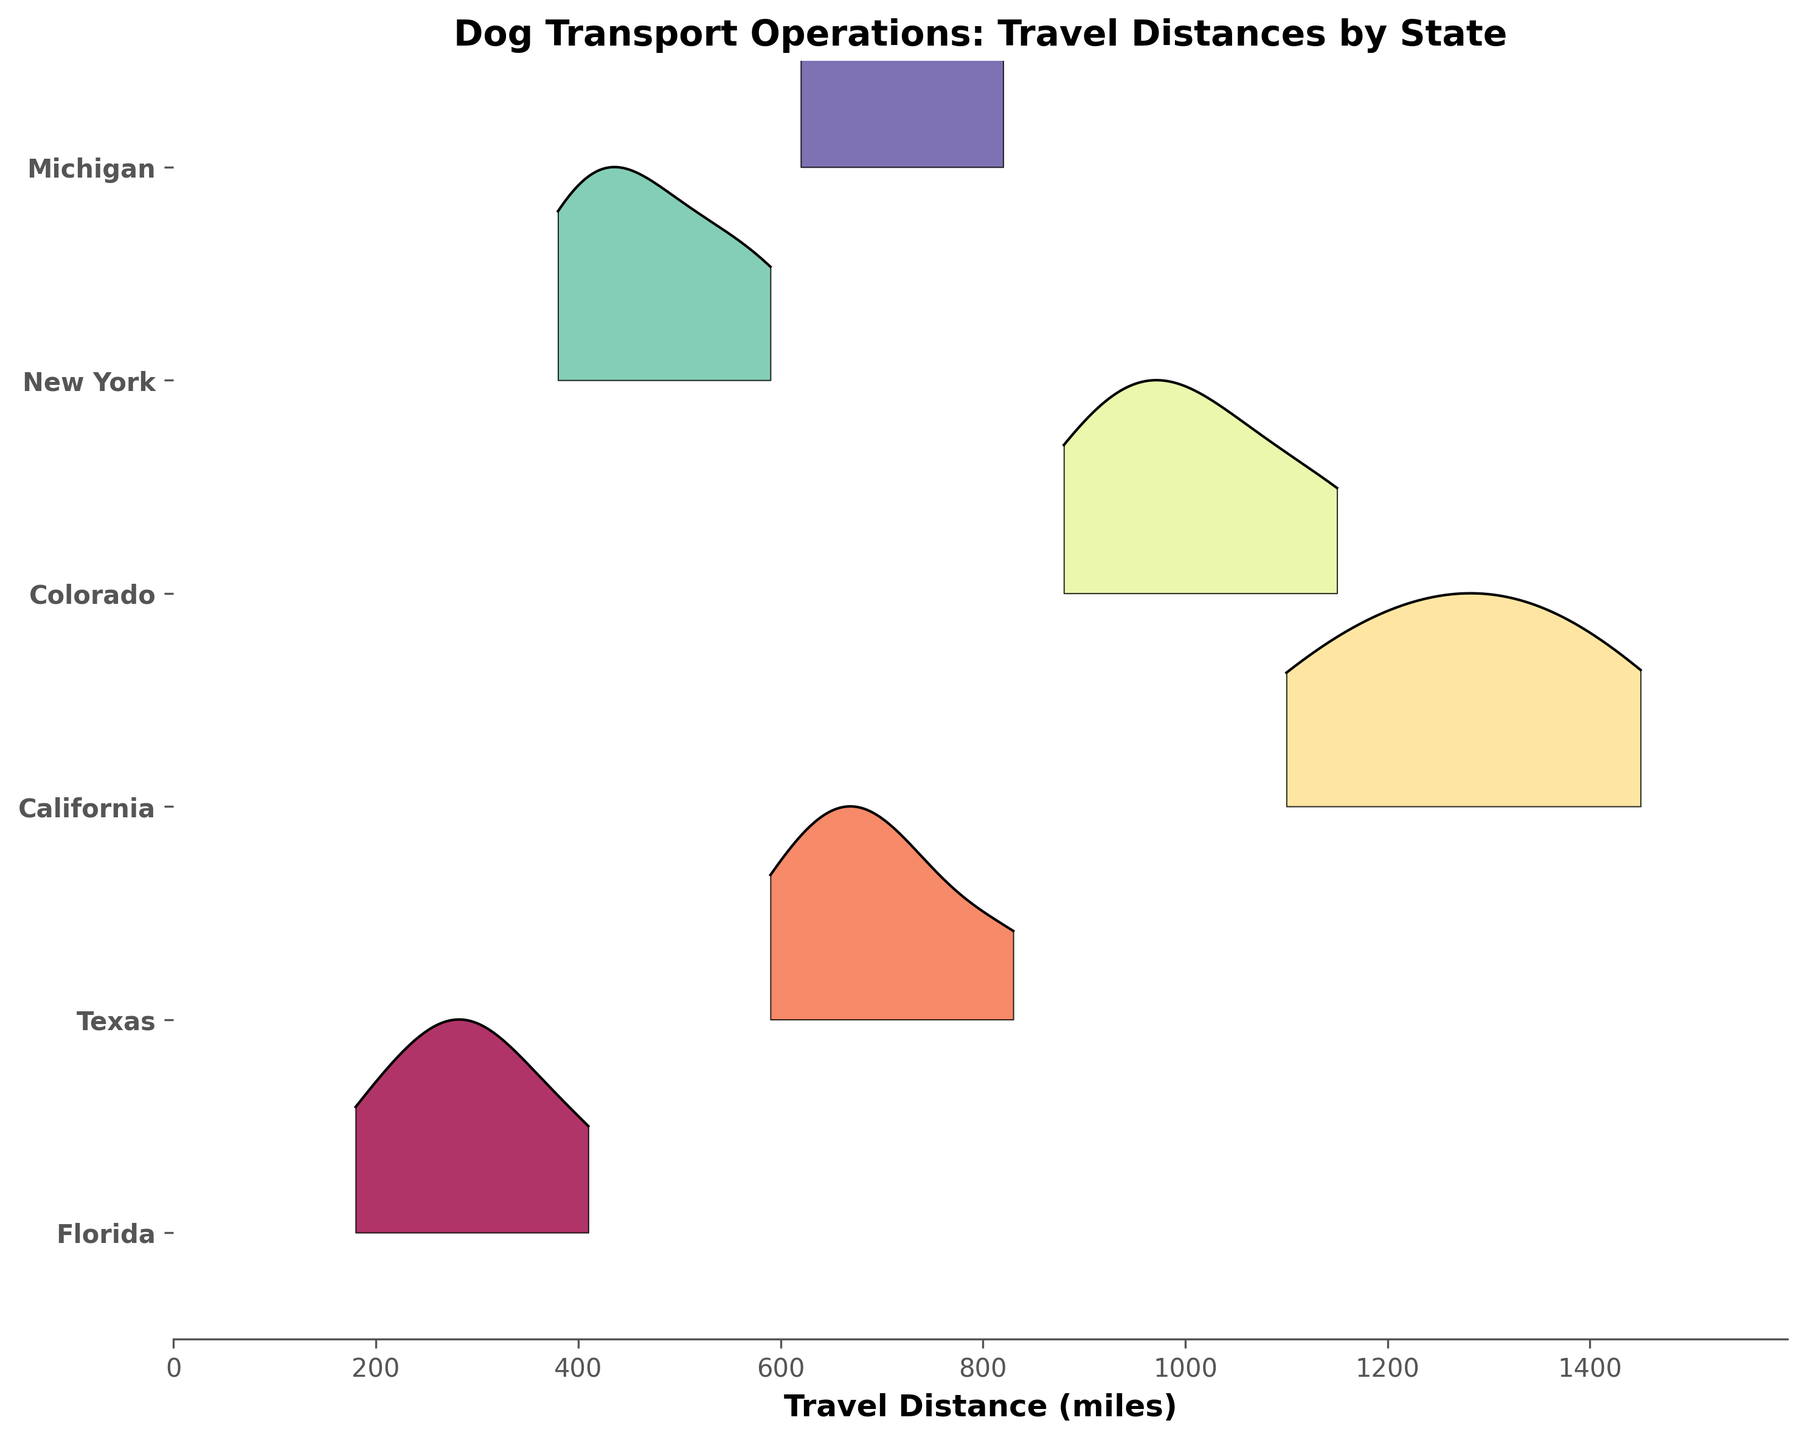Which state has the highest peak in travel distances on the plot? The height of the peak in a ridgeline plot indicates the highest density of data points at a certain travel distance. By looking at the plot, identify which state's ridgeline has the tallest peak.
Answer: California What is the title of the plot? The title is usually located at the top center of the plot, clearly describing what the plot represents.
Answer: Dog Transport Operations: Travel Distances by State Which state appears to have the smallest range of travel distances? The range of travel distances can be identified by the width of the ridgeline for each state. The state with the narrowest ridgeline has the smallest range.
Answer: Florida Compare the travel distances between Florida and New York; which state has the longer average travel distance? To find the average travel distance, look at the ridgeline plots for both states and compare the central tendency of the travel distances. New York's plot should be shifted further to the right compared to Florida's plot.
Answer: New York Which state has travel distances mostly centered around 1000 miles? The state with travel distances mostly centered around 1000 miles will have its peak density around this value. By examining where the ridgeline centers for each state, identify the state.
Answer: Colorado Where is the highest frequency of travel distances for Texas? By looking at the peak of the ridgeline for Texas, identify the travel distance where the most data points are centered. This will be at the highest point of the Texas ridgeline plot.
Answer: Around 700 miles How does the data for Michigan travel distances compare to Texas in terms of variability? Variability can be visually assessed by the width of the ridgeline. Michigan and Texas ridgelines should be compared to see which one spans over a wider range, indicating higher variability.
Answer: Michigan has similar variability to Texas Which states have ridgelines that overlap around the 600-mile mark? By examining where the ridgelines for different states overlap around the 600-mile mark, find the states that share this common travel distance.
Answer: Texas and Michigan What color represents the ridgeline for California? Each state's ridgeline is represented by a unique color. Identify the color assigned to California by referring to the plot.
Answer: The specific color varies based on the color map but typically a distinctive shade in the spectrum Which state has travel distances that do not exceed 900 miles? By identifying ridgelines that do not extend past the 900-mile mark on the x-axis, find the corresponding state.
Answer: Florida 